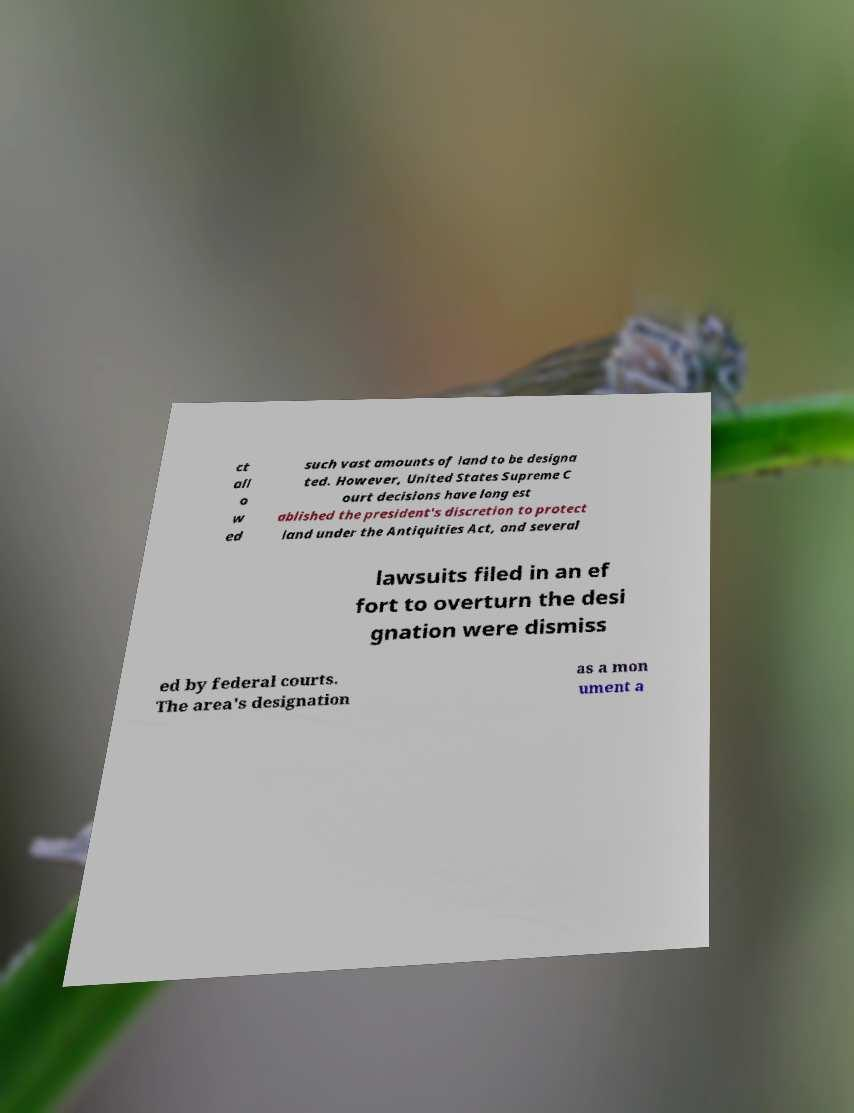There's text embedded in this image that I need extracted. Can you transcribe it verbatim? ct all o w ed such vast amounts of land to be designa ted. However, United States Supreme C ourt decisions have long est ablished the president's discretion to protect land under the Antiquities Act, and several lawsuits filed in an ef fort to overturn the desi gnation were dismiss ed by federal courts. The area's designation as a mon ument a 